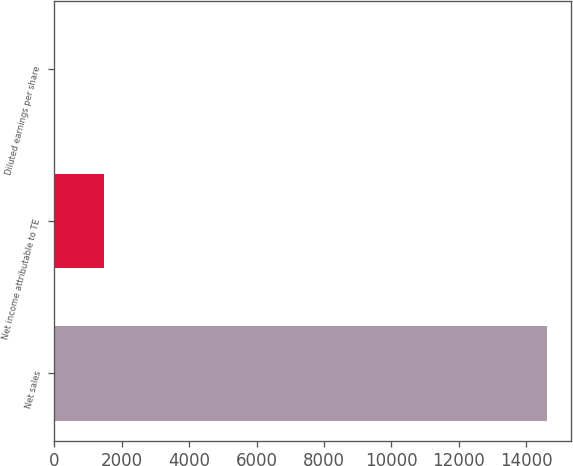<chart> <loc_0><loc_0><loc_500><loc_500><bar_chart><fcel>Net sales<fcel>Net income attributable to TE<fcel>Diluted earnings per share<nl><fcel>14612<fcel>1463.69<fcel>2.77<nl></chart> 